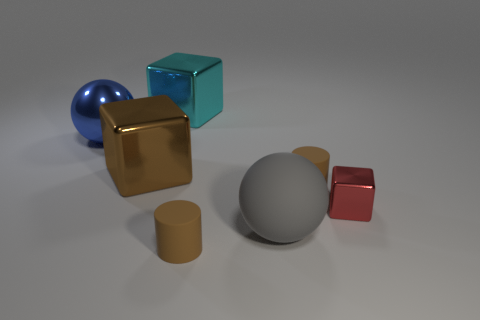Add 1 big gray spheres. How many objects exist? 8 Subtract all cylinders. How many objects are left? 5 Add 6 metal blocks. How many metal blocks exist? 9 Subtract 0 yellow balls. How many objects are left? 7 Subtract all big metal spheres. Subtract all small things. How many objects are left? 3 Add 1 blue objects. How many blue objects are left? 2 